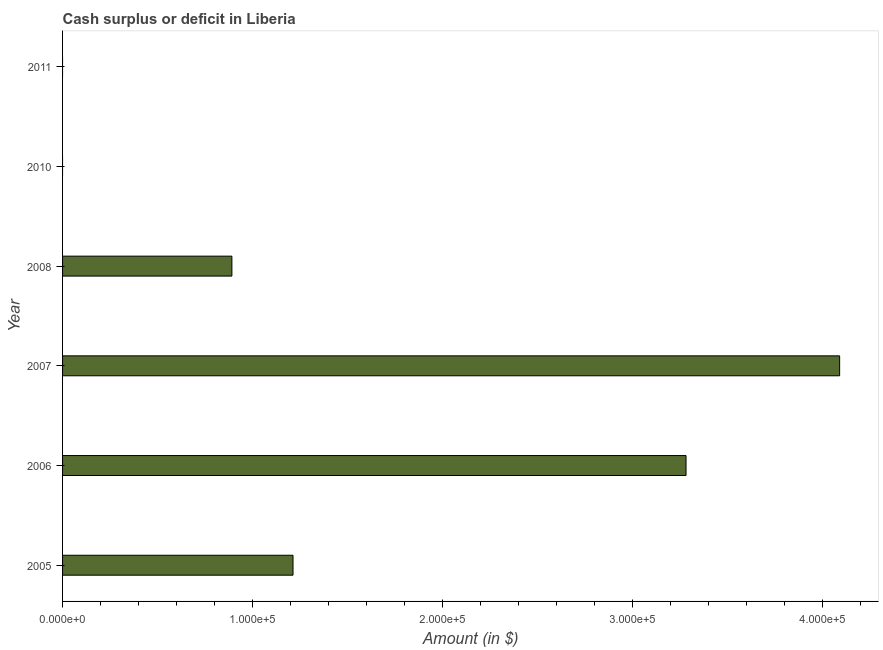Does the graph contain any zero values?
Ensure brevity in your answer.  Yes. What is the title of the graph?
Your answer should be compact. Cash surplus or deficit in Liberia. What is the label or title of the X-axis?
Keep it short and to the point. Amount (in $). What is the cash surplus or deficit in 2010?
Make the answer very short. 0. Across all years, what is the maximum cash surplus or deficit?
Give a very brief answer. 4.09e+05. In which year was the cash surplus or deficit maximum?
Make the answer very short. 2007. What is the sum of the cash surplus or deficit?
Provide a short and direct response. 9.47e+05. What is the difference between the cash surplus or deficit in 2006 and 2007?
Your answer should be very brief. -8.08e+04. What is the average cash surplus or deficit per year?
Make the answer very short. 1.58e+05. What is the median cash surplus or deficit?
Keep it short and to the point. 1.05e+05. What is the ratio of the cash surplus or deficit in 2006 to that in 2008?
Provide a short and direct response. 3.68. Is the cash surplus or deficit in 2006 less than that in 2008?
Your response must be concise. No. Is the difference between the cash surplus or deficit in 2005 and 2008 greater than the difference between any two years?
Your answer should be very brief. No. What is the difference between the highest and the second highest cash surplus or deficit?
Your response must be concise. 8.08e+04. Is the sum of the cash surplus or deficit in 2005 and 2008 greater than the maximum cash surplus or deficit across all years?
Offer a very short reply. No. What is the difference between the highest and the lowest cash surplus or deficit?
Provide a succinct answer. 4.09e+05. Are all the bars in the graph horizontal?
Make the answer very short. Yes. How many years are there in the graph?
Your answer should be very brief. 6. What is the Amount (in $) of 2005?
Ensure brevity in your answer.  1.21e+05. What is the Amount (in $) in 2006?
Your response must be concise. 3.28e+05. What is the Amount (in $) in 2007?
Offer a very short reply. 4.09e+05. What is the Amount (in $) in 2008?
Ensure brevity in your answer.  8.91e+04. What is the Amount (in $) of 2011?
Give a very brief answer. 0. What is the difference between the Amount (in $) in 2005 and 2006?
Make the answer very short. -2.07e+05. What is the difference between the Amount (in $) in 2005 and 2007?
Provide a succinct answer. -2.88e+05. What is the difference between the Amount (in $) in 2005 and 2008?
Give a very brief answer. 3.22e+04. What is the difference between the Amount (in $) in 2006 and 2007?
Your answer should be very brief. -8.08e+04. What is the difference between the Amount (in $) in 2006 and 2008?
Your answer should be very brief. 2.39e+05. What is the difference between the Amount (in $) in 2007 and 2008?
Your answer should be compact. 3.20e+05. What is the ratio of the Amount (in $) in 2005 to that in 2006?
Your answer should be very brief. 0.37. What is the ratio of the Amount (in $) in 2005 to that in 2007?
Provide a succinct answer. 0.3. What is the ratio of the Amount (in $) in 2005 to that in 2008?
Your answer should be compact. 1.36. What is the ratio of the Amount (in $) in 2006 to that in 2007?
Offer a terse response. 0.8. What is the ratio of the Amount (in $) in 2006 to that in 2008?
Your answer should be compact. 3.68. What is the ratio of the Amount (in $) in 2007 to that in 2008?
Make the answer very short. 4.59. 